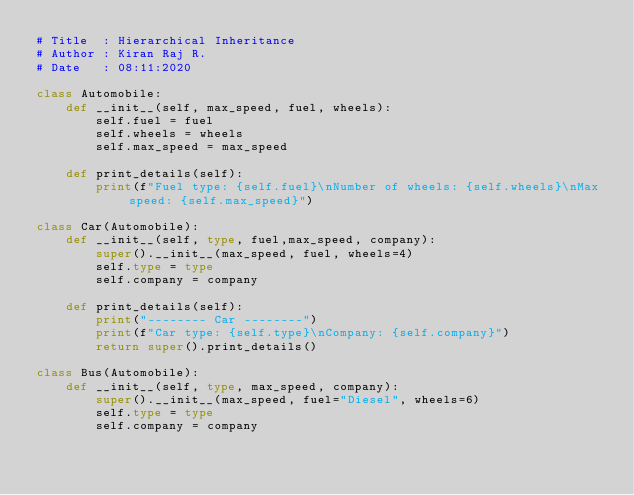Convert code to text. <code><loc_0><loc_0><loc_500><loc_500><_Python_># Title  : Hierarchical Inheritance
# Author : Kiran Raj R.
# Date   : 08:11:2020

class Automobile:
    def __init__(self, max_speed, fuel, wheels):
        self.fuel = fuel
        self.wheels = wheels
        self.max_speed = max_speed
    
    def print_details(self):
        print(f"Fuel type: {self.fuel}\nNumber of wheels: {self.wheels}\nMax speed: {self.max_speed}")
    
class Car(Automobile):
    def __init__(self, type, fuel,max_speed, company):
        super().__init__(max_speed, fuel, wheels=4)
        self.type = type
        self.company = company
    
    def print_details(self):
        print("-------- Car --------")
        print(f"Car type: {self.type}\nCompany: {self.company}")
        return super().print_details()

class Bus(Automobile):
    def __init__(self, type, max_speed, company):
        super().__init__(max_speed, fuel="Diesel", wheels=6)
        self.type = type
        self.company = company
    </code> 